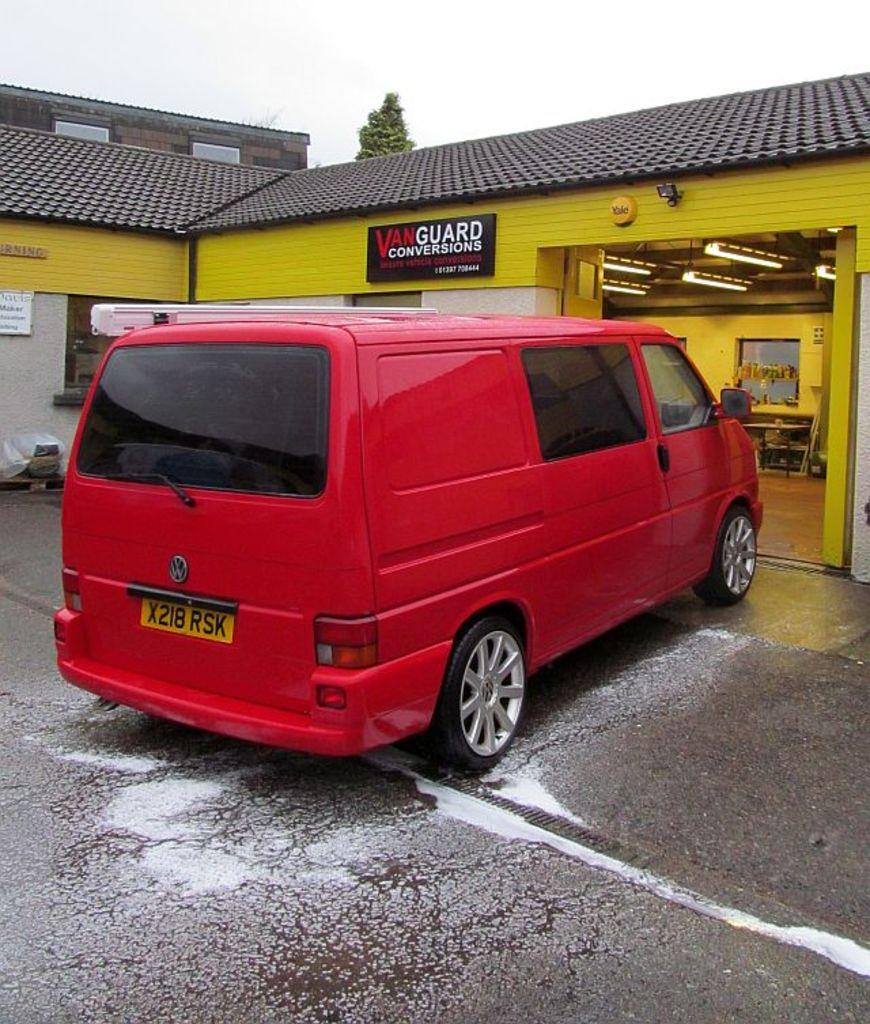What is located in front of the shed in the image? There is a vehicle in front of the shed in the image. Where are the lights positioned in the image? The lights are on the right side of the image. What is attached to the wall in the image? There is a board on the wall in the image. What is visible at the top of the image? The sky is visible at the top of the image. What type of flower is growing on the edge of the shed in the image? There is no flower growing on the edge of the shed in the image. Can you describe the branch that is hanging from the lights in the image? There is no branch hanging from the lights in the image. 